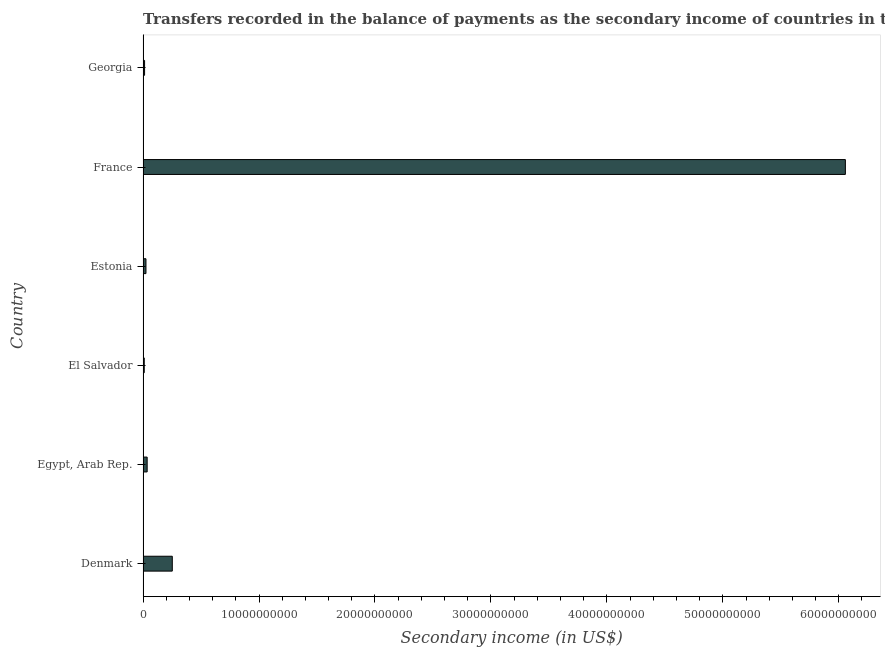Does the graph contain any zero values?
Make the answer very short. No. What is the title of the graph?
Your answer should be very brief. Transfers recorded in the balance of payments as the secondary income of countries in the year 2014. What is the label or title of the X-axis?
Offer a very short reply. Secondary income (in US$). What is the label or title of the Y-axis?
Keep it short and to the point. Country. What is the amount of secondary income in Georgia?
Your answer should be very brief. 1.31e+08. Across all countries, what is the maximum amount of secondary income?
Make the answer very short. 6.06e+1. Across all countries, what is the minimum amount of secondary income?
Offer a terse response. 1.03e+08. In which country was the amount of secondary income maximum?
Make the answer very short. France. In which country was the amount of secondary income minimum?
Ensure brevity in your answer.  El Salvador. What is the sum of the amount of secondary income?
Your response must be concise. 6.39e+1. What is the difference between the amount of secondary income in Egypt, Arab Rep. and Estonia?
Ensure brevity in your answer.  1.03e+08. What is the average amount of secondary income per country?
Make the answer very short. 1.07e+1. What is the median amount of secondary income?
Offer a terse response. 3.02e+08. In how many countries, is the amount of secondary income greater than 56000000000 US$?
Your answer should be very brief. 1. What is the ratio of the amount of secondary income in El Salvador to that in France?
Give a very brief answer. 0. What is the difference between the highest and the second highest amount of secondary income?
Give a very brief answer. 5.80e+1. What is the difference between the highest and the lowest amount of secondary income?
Keep it short and to the point. 6.05e+1. How many countries are there in the graph?
Make the answer very short. 6. What is the Secondary income (in US$) of Denmark?
Provide a succinct answer. 2.52e+09. What is the Secondary income (in US$) in Egypt, Arab Rep.?
Give a very brief answer. 3.54e+08. What is the Secondary income (in US$) in El Salvador?
Make the answer very short. 1.03e+08. What is the Secondary income (in US$) in Estonia?
Give a very brief answer. 2.50e+08. What is the Secondary income (in US$) in France?
Provide a succinct answer. 6.06e+1. What is the Secondary income (in US$) in Georgia?
Provide a short and direct response. 1.31e+08. What is the difference between the Secondary income (in US$) in Denmark and Egypt, Arab Rep.?
Provide a short and direct response. 2.17e+09. What is the difference between the Secondary income (in US$) in Denmark and El Salvador?
Your response must be concise. 2.42e+09. What is the difference between the Secondary income (in US$) in Denmark and Estonia?
Ensure brevity in your answer.  2.27e+09. What is the difference between the Secondary income (in US$) in Denmark and France?
Make the answer very short. -5.80e+1. What is the difference between the Secondary income (in US$) in Denmark and Georgia?
Give a very brief answer. 2.39e+09. What is the difference between the Secondary income (in US$) in Egypt, Arab Rep. and El Salvador?
Your response must be concise. 2.51e+08. What is the difference between the Secondary income (in US$) in Egypt, Arab Rep. and Estonia?
Your response must be concise. 1.03e+08. What is the difference between the Secondary income (in US$) in Egypt, Arab Rep. and France?
Keep it short and to the point. -6.02e+1. What is the difference between the Secondary income (in US$) in Egypt, Arab Rep. and Georgia?
Give a very brief answer. 2.23e+08. What is the difference between the Secondary income (in US$) in El Salvador and Estonia?
Make the answer very short. -1.48e+08. What is the difference between the Secondary income (in US$) in El Salvador and France?
Make the answer very short. -6.05e+1. What is the difference between the Secondary income (in US$) in El Salvador and Georgia?
Offer a terse response. -2.83e+07. What is the difference between the Secondary income (in US$) in Estonia and France?
Provide a succinct answer. -6.03e+1. What is the difference between the Secondary income (in US$) in Estonia and Georgia?
Your answer should be very brief. 1.19e+08. What is the difference between the Secondary income (in US$) in France and Georgia?
Ensure brevity in your answer.  6.04e+1. What is the ratio of the Secondary income (in US$) in Denmark to that in Egypt, Arab Rep.?
Keep it short and to the point. 7.13. What is the ratio of the Secondary income (in US$) in Denmark to that in El Salvador?
Offer a very short reply. 24.56. What is the ratio of the Secondary income (in US$) in Denmark to that in Estonia?
Ensure brevity in your answer.  10.07. What is the ratio of the Secondary income (in US$) in Denmark to that in France?
Offer a very short reply. 0.04. What is the ratio of the Secondary income (in US$) in Denmark to that in Georgia?
Your answer should be very brief. 19.25. What is the ratio of the Secondary income (in US$) in Egypt, Arab Rep. to that in El Salvador?
Provide a succinct answer. 3.44. What is the ratio of the Secondary income (in US$) in Egypt, Arab Rep. to that in Estonia?
Keep it short and to the point. 1.41. What is the ratio of the Secondary income (in US$) in Egypt, Arab Rep. to that in France?
Offer a terse response. 0.01. What is the ratio of the Secondary income (in US$) in El Salvador to that in Estonia?
Offer a very short reply. 0.41. What is the ratio of the Secondary income (in US$) in El Salvador to that in France?
Offer a very short reply. 0. What is the ratio of the Secondary income (in US$) in El Salvador to that in Georgia?
Your answer should be very brief. 0.78. What is the ratio of the Secondary income (in US$) in Estonia to that in France?
Your response must be concise. 0. What is the ratio of the Secondary income (in US$) in Estonia to that in Georgia?
Your answer should be very brief. 1.91. What is the ratio of the Secondary income (in US$) in France to that in Georgia?
Offer a terse response. 462.64. 